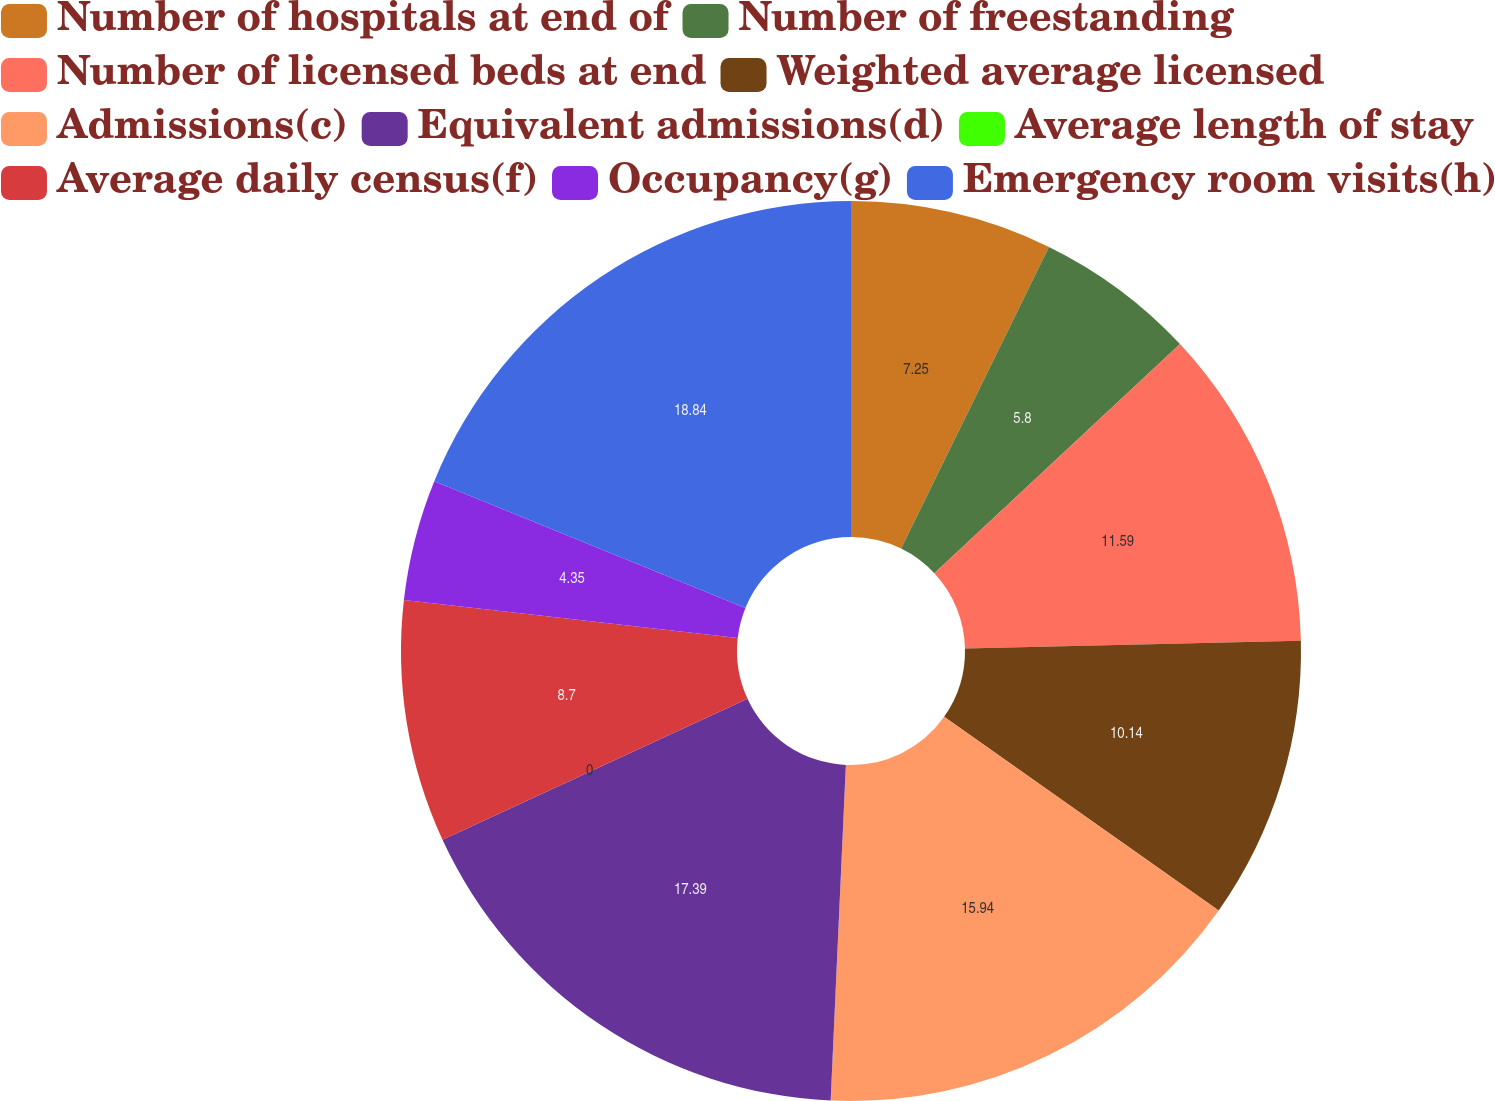Convert chart. <chart><loc_0><loc_0><loc_500><loc_500><pie_chart><fcel>Number of hospitals at end of<fcel>Number of freestanding<fcel>Number of licensed beds at end<fcel>Weighted average licensed<fcel>Admissions(c)<fcel>Equivalent admissions(d)<fcel>Average length of stay<fcel>Average daily census(f)<fcel>Occupancy(g)<fcel>Emergency room visits(h)<nl><fcel>7.25%<fcel>5.8%<fcel>11.59%<fcel>10.14%<fcel>15.94%<fcel>17.39%<fcel>0.0%<fcel>8.7%<fcel>4.35%<fcel>18.84%<nl></chart> 